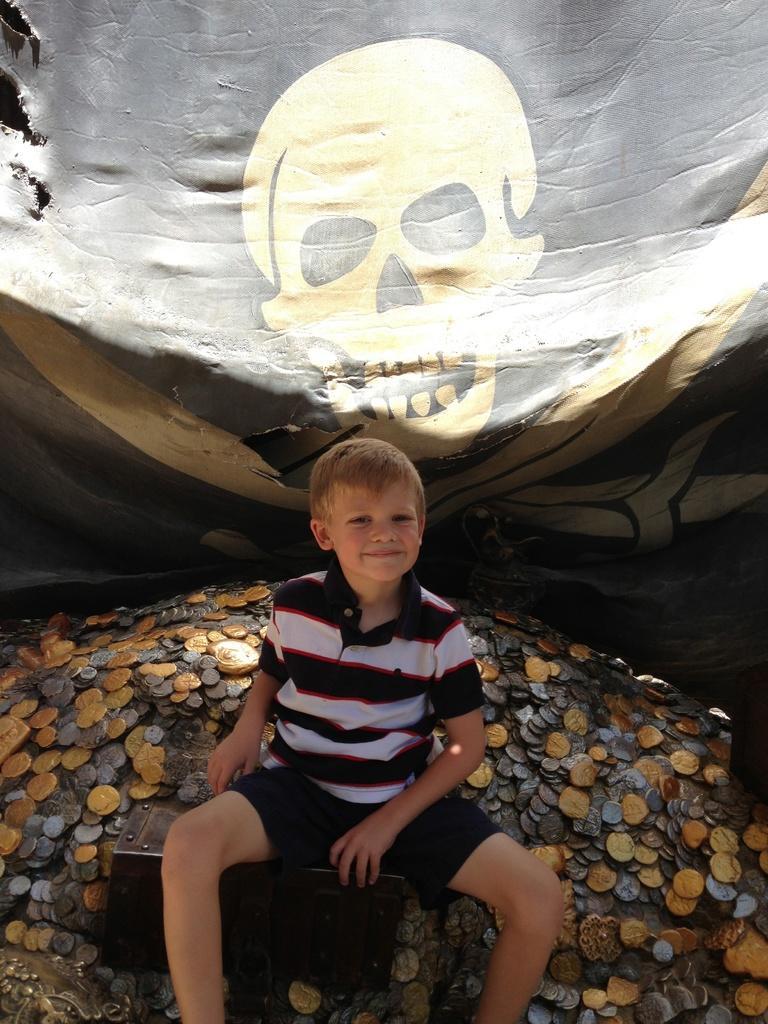How would you summarize this image in a sentence or two? In this image we can see a boy sitting on a box. Also there are coins. In the back there is a banner. On the banner there is a drawing of a skull. 